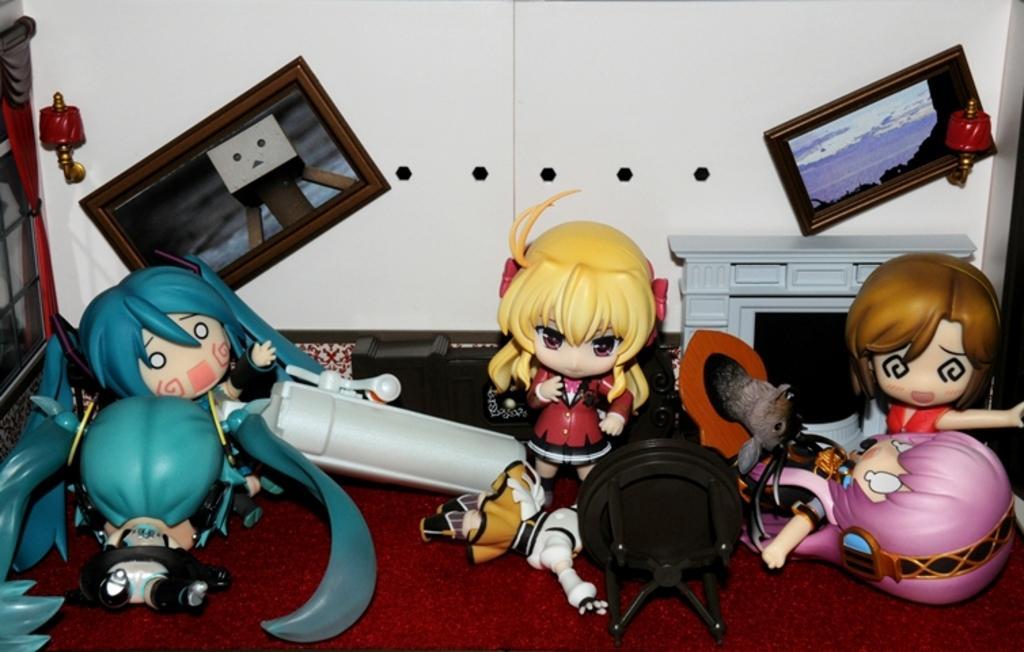Can you describe this image briefly? In this image, we can see some toys, there is a white color wall and we can see some photos on the wall. 